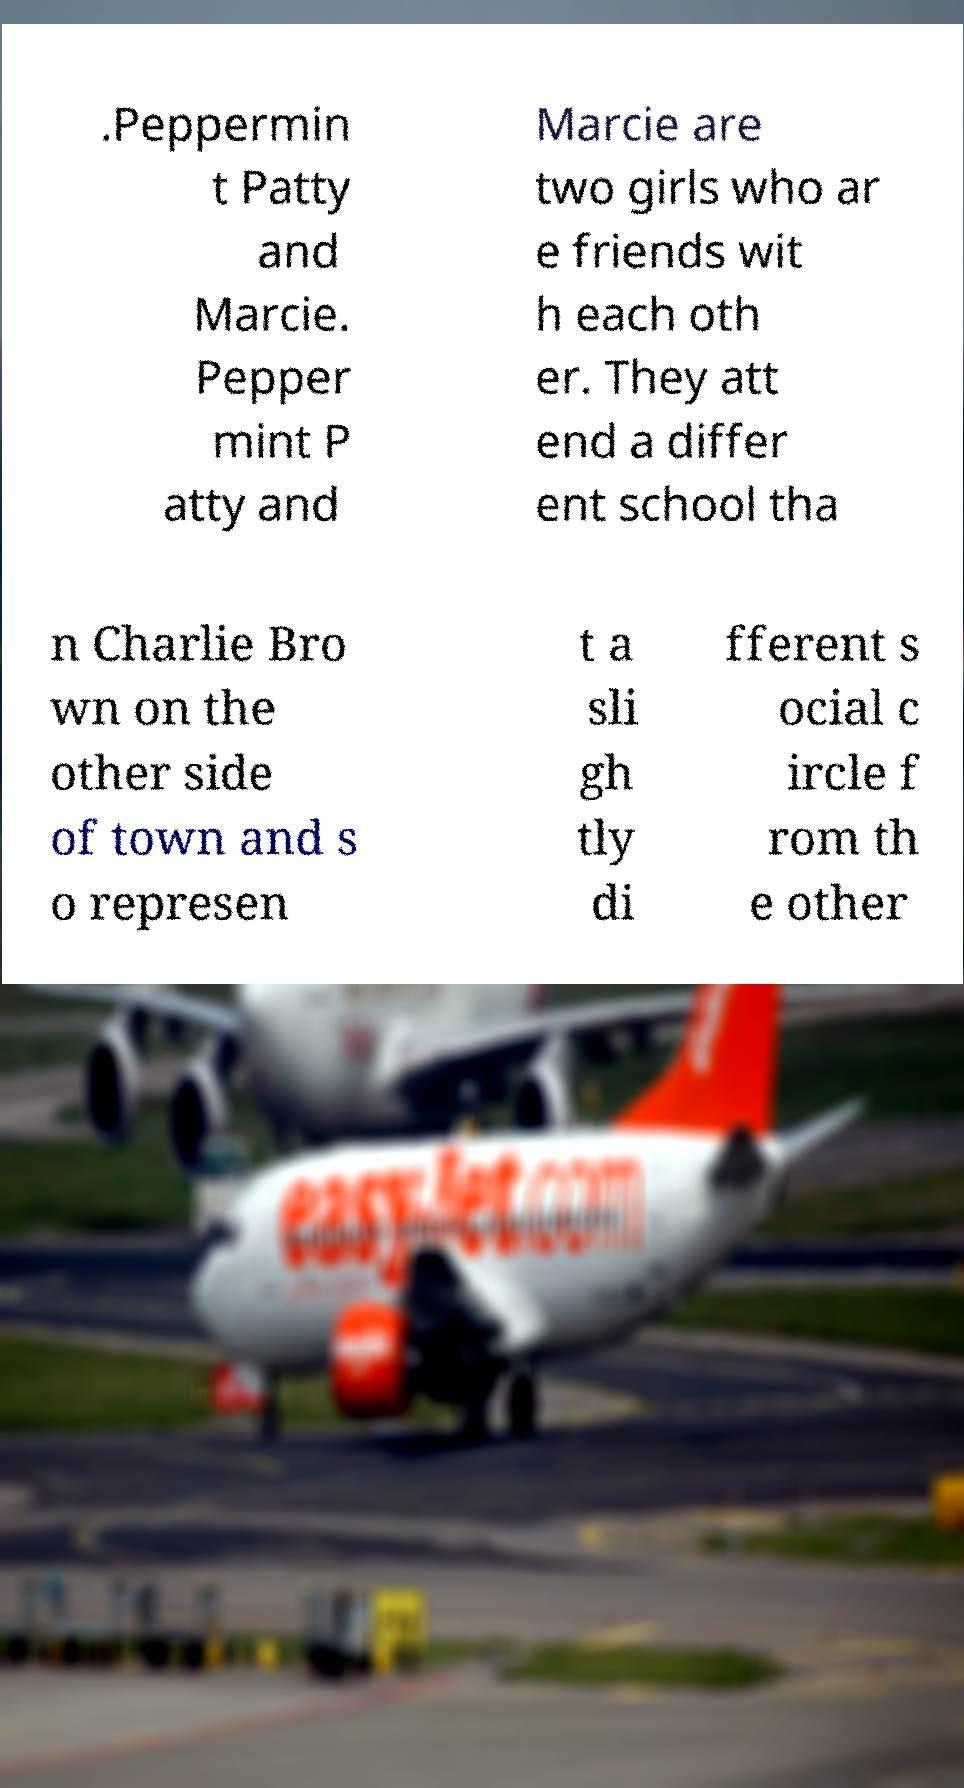What messages or text are displayed in this image? I need them in a readable, typed format. .Peppermin t Patty and Marcie. Pepper mint P atty and Marcie are two girls who ar e friends wit h each oth er. They att end a differ ent school tha n Charlie Bro wn on the other side of town and s o represen t a sli gh tly di fferent s ocial c ircle f rom th e other 